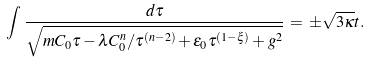<formula> <loc_0><loc_0><loc_500><loc_500>\int \, \frac { d \tau } { \sqrt { m C _ { 0 } \tau - \lambda C _ { 0 } ^ { n } / \tau ^ { ( n - 2 ) } + \varepsilon _ { 0 } \tau ^ { ( 1 - \xi ) } + g ^ { 2 } } } \, = \, \pm \sqrt { 3 \kappa } t .</formula> 